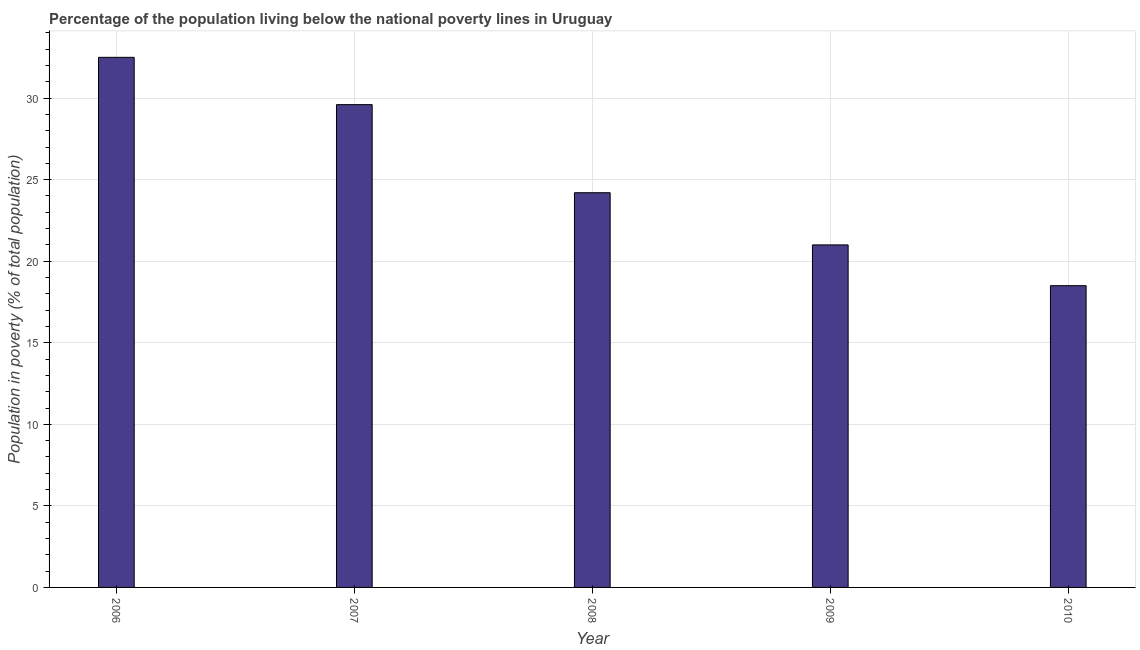What is the title of the graph?
Your answer should be compact. Percentage of the population living below the national poverty lines in Uruguay. What is the label or title of the X-axis?
Your answer should be compact. Year. What is the label or title of the Y-axis?
Make the answer very short. Population in poverty (% of total population). What is the percentage of population living below poverty line in 2008?
Offer a very short reply. 24.2. Across all years, what is the maximum percentage of population living below poverty line?
Keep it short and to the point. 32.5. Across all years, what is the minimum percentage of population living below poverty line?
Ensure brevity in your answer.  18.5. In which year was the percentage of population living below poverty line maximum?
Provide a short and direct response. 2006. In which year was the percentage of population living below poverty line minimum?
Make the answer very short. 2010. What is the sum of the percentage of population living below poverty line?
Offer a terse response. 125.8. What is the difference between the percentage of population living below poverty line in 2007 and 2008?
Offer a terse response. 5.4. What is the average percentage of population living below poverty line per year?
Your answer should be very brief. 25.16. What is the median percentage of population living below poverty line?
Your response must be concise. 24.2. What is the ratio of the percentage of population living below poverty line in 2007 to that in 2010?
Keep it short and to the point. 1.6. What is the difference between the highest and the lowest percentage of population living below poverty line?
Offer a terse response. 14. In how many years, is the percentage of population living below poverty line greater than the average percentage of population living below poverty line taken over all years?
Offer a terse response. 2. What is the difference between two consecutive major ticks on the Y-axis?
Your answer should be very brief. 5. Are the values on the major ticks of Y-axis written in scientific E-notation?
Your answer should be very brief. No. What is the Population in poverty (% of total population) in 2006?
Provide a succinct answer. 32.5. What is the Population in poverty (% of total population) in 2007?
Offer a very short reply. 29.6. What is the Population in poverty (% of total population) in 2008?
Your answer should be very brief. 24.2. What is the difference between the Population in poverty (% of total population) in 2006 and 2007?
Offer a terse response. 2.9. What is the difference between the Population in poverty (% of total population) in 2007 and 2008?
Provide a short and direct response. 5.4. What is the difference between the Population in poverty (% of total population) in 2007 and 2009?
Make the answer very short. 8.6. What is the difference between the Population in poverty (% of total population) in 2007 and 2010?
Your response must be concise. 11.1. What is the difference between the Population in poverty (% of total population) in 2008 and 2009?
Ensure brevity in your answer.  3.2. What is the ratio of the Population in poverty (% of total population) in 2006 to that in 2007?
Give a very brief answer. 1.1. What is the ratio of the Population in poverty (% of total population) in 2006 to that in 2008?
Your answer should be compact. 1.34. What is the ratio of the Population in poverty (% of total population) in 2006 to that in 2009?
Offer a terse response. 1.55. What is the ratio of the Population in poverty (% of total population) in 2006 to that in 2010?
Keep it short and to the point. 1.76. What is the ratio of the Population in poverty (% of total population) in 2007 to that in 2008?
Make the answer very short. 1.22. What is the ratio of the Population in poverty (% of total population) in 2007 to that in 2009?
Give a very brief answer. 1.41. What is the ratio of the Population in poverty (% of total population) in 2008 to that in 2009?
Offer a terse response. 1.15. What is the ratio of the Population in poverty (% of total population) in 2008 to that in 2010?
Offer a terse response. 1.31. What is the ratio of the Population in poverty (% of total population) in 2009 to that in 2010?
Keep it short and to the point. 1.14. 